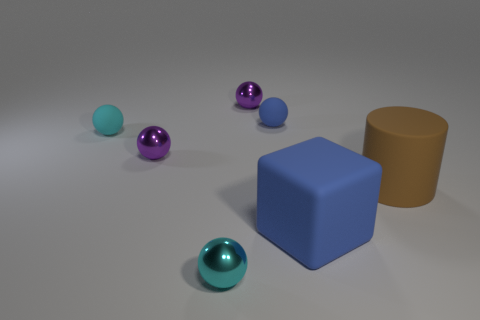Subtract 2 spheres. How many spheres are left? 3 Subtract all blue spheres. How many spheres are left? 4 Subtract all blue rubber spheres. How many spheres are left? 4 Add 1 tiny spheres. How many objects exist? 8 Subtract all brown balls. Subtract all green cubes. How many balls are left? 5 Subtract all cubes. How many objects are left? 6 Subtract all large things. Subtract all large matte cylinders. How many objects are left? 4 Add 5 cyan rubber objects. How many cyan rubber objects are left? 6 Add 6 cyan cylinders. How many cyan cylinders exist? 6 Subtract 0 purple cylinders. How many objects are left? 7 